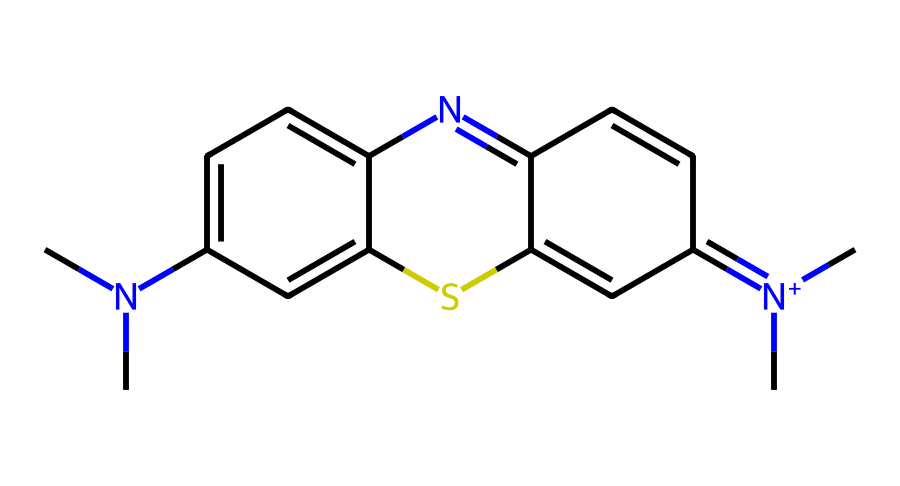What is the molecular formula of Methylene blue? By interpreting the SMILES notation, we identify the atoms present: carbon (C), hydrogen (H), nitrogen (N), and sulfur (S). Counting these gives us C16H18ClN3S.
Answer: C16H18ClN3S How many nitrogen atoms are present in Methylene blue? The SMILES indicates nitrogen atoms with "N" present. Counting the "N" symbols shows there are three nitrogen atoms in total.
Answer: 3 What is the primary color of Methylene blue when used as a dye? Methylene blue typically produces a deep blue color when used as a dye, which is a characteristic feature of this compound.
Answer: blue What type of dye is Methylene blue classified as? Methylene blue is classified as a cationic dye because it carries a positive charge in its chemical structure, which is indicated by the presence of the quaternary nitrogen atom (N+).
Answer: cationic Which atom contributes to the cationic nature of Methylene blue? The presence of the positively charged nitrogen (N+) indicates that this atom contributes to the cationic nature of the dye.
Answer: nitrogen What is the significance of the sulfur atom in Methylene blue? The sulfur in Methylene blue is part of a thiophene ring structure which can influence the dye's light absorption characteristics, contributing to its effectiveness as a dye.
Answer: thiophene 